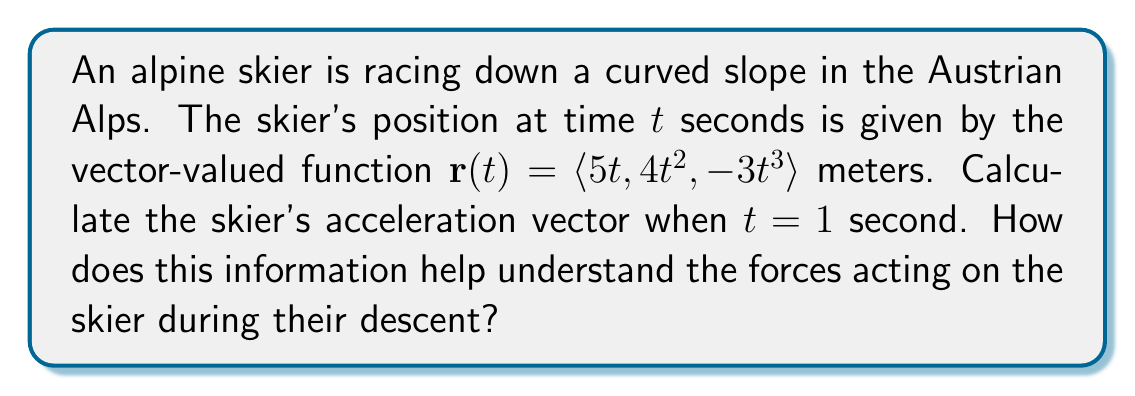Can you answer this question? To solve this problem, we need to follow these steps:

1) The velocity vector $\mathbf{v}(t)$ is the first derivative of the position vector $\mathbf{r}(t)$:

   $$\mathbf{v}(t) = \frac{d}{dt}\mathbf{r}(t) = \langle \frac{d}{dt}(5t), \frac{d}{dt}(4t^2), \frac{d}{dt}(-3t^3) \rangle$$
   $$\mathbf{v}(t) = \langle 5, 8t, -9t^2 \rangle$$

2) The acceleration vector $\mathbf{a}(t)$ is the second derivative of the position vector, or the first derivative of the velocity vector:

   $$\mathbf{a}(t) = \frac{d}{dt}\mathbf{v}(t) = \langle \frac{d}{dt}(5), \frac{d}{dt}(8t), \frac{d}{dt}(-9t^2) \rangle$$
   $$\mathbf{a}(t) = \langle 0, 8, -18t \rangle$$

3) To find the acceleration at $t = 1$ second, we substitute $t = 1$ into our acceleration function:

   $$\mathbf{a}(1) = \langle 0, 8, -18 \rangle$$

This result tells us that at $t = 1$ second:
- The skier has no acceleration in the x-direction (horizontal plane).
- The skier is accelerating at 8 m/s² in the positive y-direction (which could represent movement across the slope).
- The skier is accelerating at 18 m/s² in the negative z-direction (which likely represents the downward acceleration due to gravity and the slope).

This information helps us understand the forces acting on the skier:
1. The lack of x-acceleration suggests the skier is moving at a constant speed horizontally.
2. The positive y-acceleration indicates the skier is moving across the slope, possibly navigating a turn.
3. The negative z-acceleration is larger in magnitude, showing the dominant force of gravity pulling the skier down the slope.

These insights could be valuable for a sports journalist to explain the technical aspects of alpine skiing to their audience, highlighting the complex forces at play during a high-speed descent.
Answer: The skier's acceleration vector at $t = 1$ second is $\mathbf{a}(1) = \langle 0, 8, -18 \rangle$ m/s². 